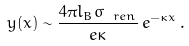<formula> <loc_0><loc_0><loc_500><loc_500>y ( x ) \sim \frac { 4 \pi l _ { B } \sigma _ { \ r e n } } { e \kappa } \, e ^ { - \kappa x } \, .</formula> 